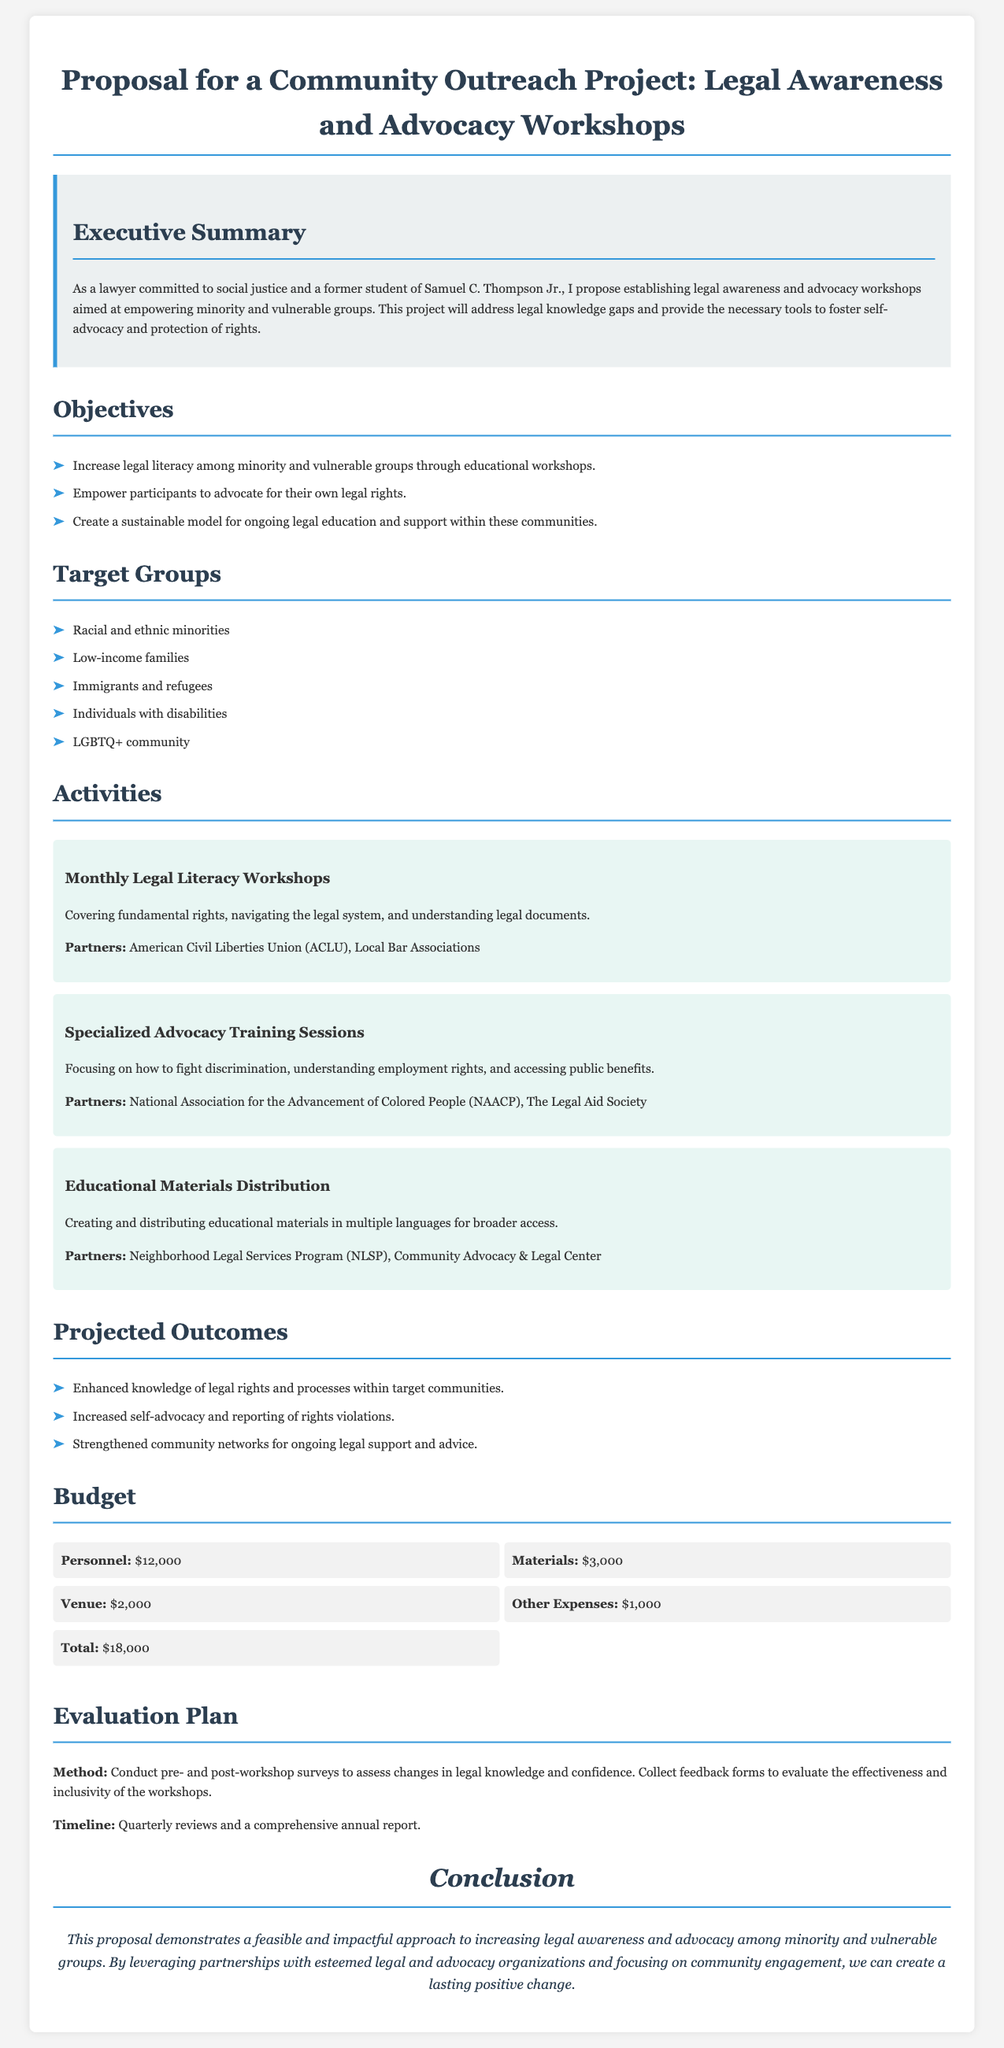What is the total budget for the project? The total budget is detailed in the budget section, which adds up to $18,000.
Answer: $18,000 Who are the partners for the Monthly Legal Literacy Workshops? The partners for the Monthly Legal Literacy Workshops are listed as the American Civil Liberties Union (ACLU) and Local Bar Associations.
Answer: American Civil Liberties Union (ACLU), Local Bar Associations What is the primary objective of the workshops? The primary objective is stated as increasing legal literacy among minority and vulnerable groups through educational workshops.
Answer: Increase legal literacy Name two target groups mentioned in the proposal. The proposal lists several target groups, including racial and ethnic minorities and low-income families.
Answer: Racial and ethnic minorities, low-income families What type of evaluation method is used for the workshops? The evaluation method consists of conducting pre- and post-workshop surveys to assess changes in legal knowledge and confidence.
Answer: Pre- and post-workshop surveys What is one of the projected outcomes of the workshops? One of the projected outcomes is the enhanced knowledge of legal rights and processes within target communities.
Answer: Enhanced knowledge of legal rights What is the venue budget? The budget for the venue is specified in the document's budget section.
Answer: $2,000 What is the main theme of the conclusion? The conclusion emphasizes the proposal's feasibility and impact on increasing legal awareness and advocacy among underserved communities.
Answer: Feasible and impactful approach Which community does the project aim to empower? The project aims to empower minority and vulnerable groups.
Answer: Minority and vulnerable groups 